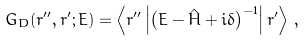<formula> <loc_0><loc_0><loc_500><loc_500>G _ { D } ( { r ^ { \prime \prime } } , { r ^ { \prime } } ; E ) = \left \langle { r } ^ { \prime \prime } \left | \left ( E - \hat { H } + i \delta \right ) ^ { - 1 } \right | { r } ^ { \prime } \right \rangle \, ,</formula> 